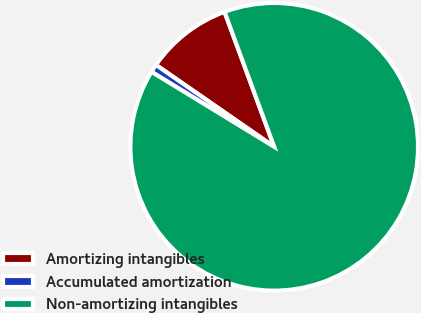Convert chart. <chart><loc_0><loc_0><loc_500><loc_500><pie_chart><fcel>Amortizing intangibles<fcel>Accumulated amortization<fcel>Non-amortizing intangibles<nl><fcel>9.75%<fcel>0.91%<fcel>89.33%<nl></chart> 